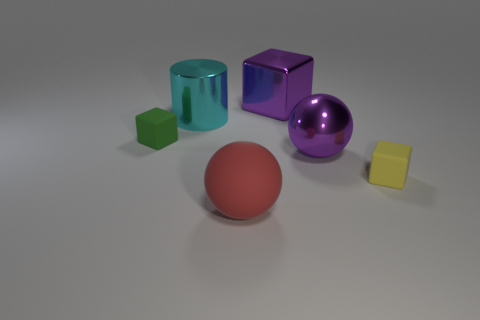Subtract all green rubber cubes. How many cubes are left? 2 Add 2 small yellow rubber cubes. How many objects exist? 8 Subtract all purple balls. How many balls are left? 1 Subtract all cyan cylinders. How many green cubes are left? 1 Subtract all big purple balls. Subtract all large purple objects. How many objects are left? 3 Add 1 small yellow blocks. How many small yellow blocks are left? 2 Add 6 small gray matte cylinders. How many small gray matte cylinders exist? 6 Subtract 1 green cubes. How many objects are left? 5 Subtract all balls. How many objects are left? 4 Subtract 1 cylinders. How many cylinders are left? 0 